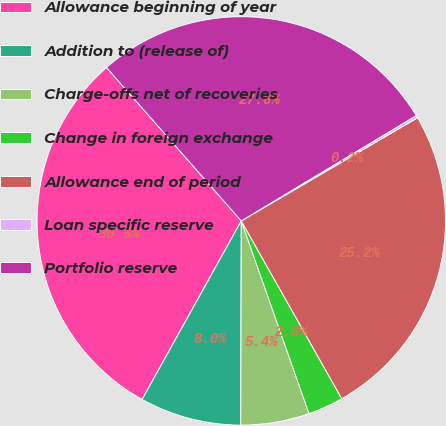Convert chart to OTSL. <chart><loc_0><loc_0><loc_500><loc_500><pie_chart><fcel>Allowance beginning of year<fcel>Addition to (release of)<fcel>Charge-offs net of recoveries<fcel>Change in foreign exchange<fcel>Allowance end of period<fcel>Loan specific reserve<fcel>Portfolio reserve<nl><fcel>30.46%<fcel>8.03%<fcel>5.42%<fcel>2.81%<fcel>25.24%<fcel>0.2%<fcel>27.85%<nl></chart> 